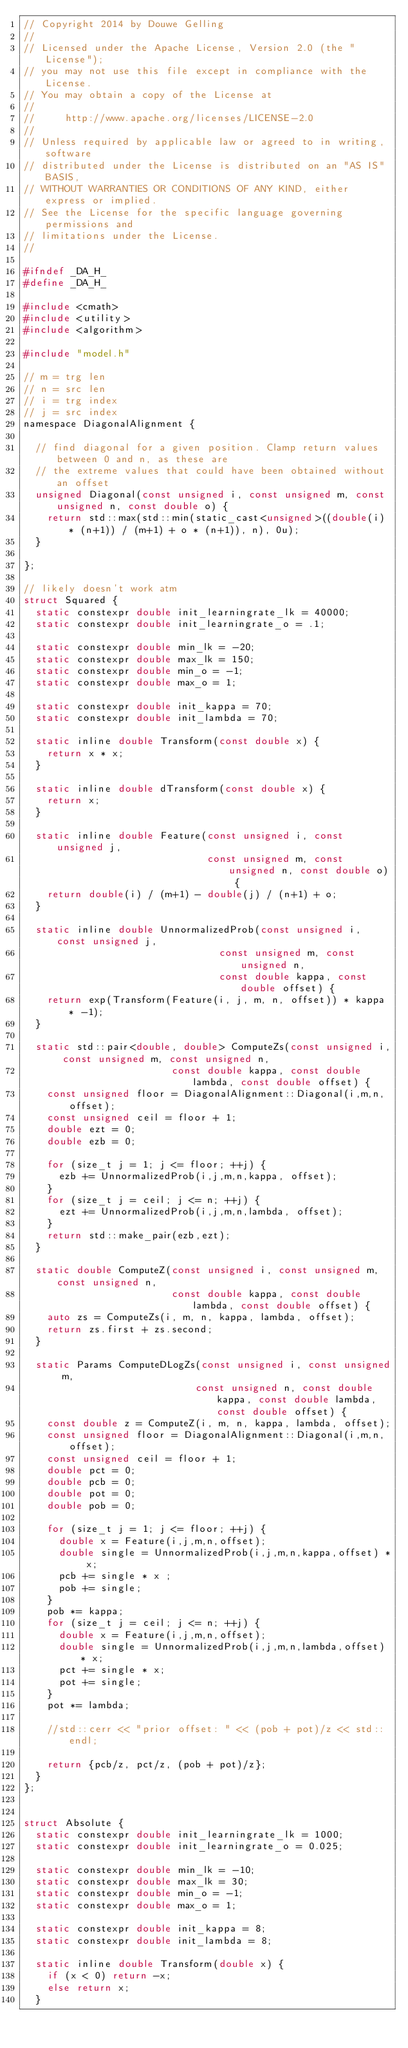Convert code to text. <code><loc_0><loc_0><loc_500><loc_500><_C_>// Copyright 2014 by Douwe Gelling
//
// Licensed under the Apache License, Version 2.0 (the "License");
// you may not use this file except in compliance with the License.
// You may obtain a copy of the License at
//
//     http://www.apache.org/licenses/LICENSE-2.0
//
// Unless required by applicable law or agreed to in writing, software
// distributed under the License is distributed on an "AS IS" BASIS,
// WITHOUT WARRANTIES OR CONDITIONS OF ANY KIND, either express or implied.
// See the License for the specific language governing permissions and
// limitations under the License.
//

#ifndef _DA_H_
#define _DA_H_

#include <cmath>
#include <utility>
#include <algorithm>

#include "model.h"

// m = trg len
// n = src len
// i = trg index
// j = src index
namespace DiagonalAlignment {

  // find diagonal for a given position. Clamp return values between 0 and n, as these are
  // the extreme values that could have been obtained without an offset
  unsigned Diagonal(const unsigned i, const unsigned m, const unsigned n, const double o) {
    return std::max(std::min(static_cast<unsigned>((double(i) * (n+1)) / (m+1) + o * (n+1)), n), 0u);
  }

};

// likely doesn't work atm
struct Squared {
  static constexpr double init_learningrate_lk = 40000;
  static constexpr double init_learningrate_o = .1;

  static constexpr double min_lk = -20;
  static constexpr double max_lk = 150;
  static constexpr double min_o = -1;
  static constexpr double max_o = 1;

  static constexpr double init_kappa = 70;
  static constexpr double init_lambda = 70;

  static inline double Transform(const double x) {
    return x * x;
  }

  static inline double dTransform(const double x) {
    return x;
  }

  static inline double Feature(const unsigned i, const unsigned j,
                               const unsigned m, const unsigned n, const double o) {
    return double(i) / (m+1) - double(j) / (n+1) + o;
  }

  static inline double UnnormalizedProb(const unsigned i, const unsigned j,
                                 const unsigned m, const unsigned n,
                                 const double kappa, const double offset) {
    return exp(Transform(Feature(i, j, m, n, offset)) * kappa * -1);
  }

  static std::pair<double, double> ComputeZs(const unsigned i, const unsigned m, const unsigned n,
                         const double kappa, const double lambda, const double offset) {
    const unsigned floor = DiagonalAlignment::Diagonal(i,m,n,offset);
    const unsigned ceil = floor + 1;
    double ezt = 0;
    double ezb = 0;

    for (size_t j = 1; j <= floor; ++j) {
      ezb += UnnormalizedProb(i,j,m,n,kappa, offset);
    }
    for (size_t j = ceil; j <= n; ++j) {
      ezt += UnnormalizedProb(i,j,m,n,lambda, offset);
    }
    return std::make_pair(ezb,ezt);
  }

  static double ComputeZ(const unsigned i, const unsigned m, const unsigned n,
                         const double kappa, const double lambda, const double offset) {
    auto zs = ComputeZs(i, m, n, kappa, lambda, offset);
    return zs.first + zs.second;
  }

  static Params ComputeDLogZs(const unsigned i, const unsigned m,
                             const unsigned n, const double kappa, const double lambda, const double offset) {
    const double z = ComputeZ(i, m, n, kappa, lambda, offset);
    const unsigned floor = DiagonalAlignment::Diagonal(i,m,n,offset);
    const unsigned ceil = floor + 1;
    double pct = 0;
    double pcb = 0;
    double pot = 0;
    double pob = 0;

    for (size_t j = 1; j <= floor; ++j) {
      double x = Feature(i,j,m,n,offset);
      double single = UnnormalizedProb(i,j,m,n,kappa,offset) * x;
      pcb += single * x ;
      pob += single;
    }
    pob *= kappa;
    for (size_t j = ceil; j <= n; ++j) {
      double x = Feature(i,j,m,n,offset);
      double single = UnnormalizedProb(i,j,m,n,lambda,offset) * x;
      pct += single * x;
      pot += single;
    }
    pot *= lambda;

    //std::cerr << "prior offset: " << (pob + pot)/z << std::endl;

    return {pcb/z, pct/z, (pob + pot)/z};
  }
};


struct Absolute {
  static constexpr double init_learningrate_lk = 1000;
  static constexpr double init_learningrate_o = 0.025;

  static constexpr double min_lk = -10;
  static constexpr double max_lk = 30;
  static constexpr double min_o = -1;
  static constexpr double max_o = 1;

  static constexpr double init_kappa = 8;
  static constexpr double init_lambda = 8;

  static inline double Transform(double x) {
    if (x < 0) return -x;
    else return x;
  }
</code> 